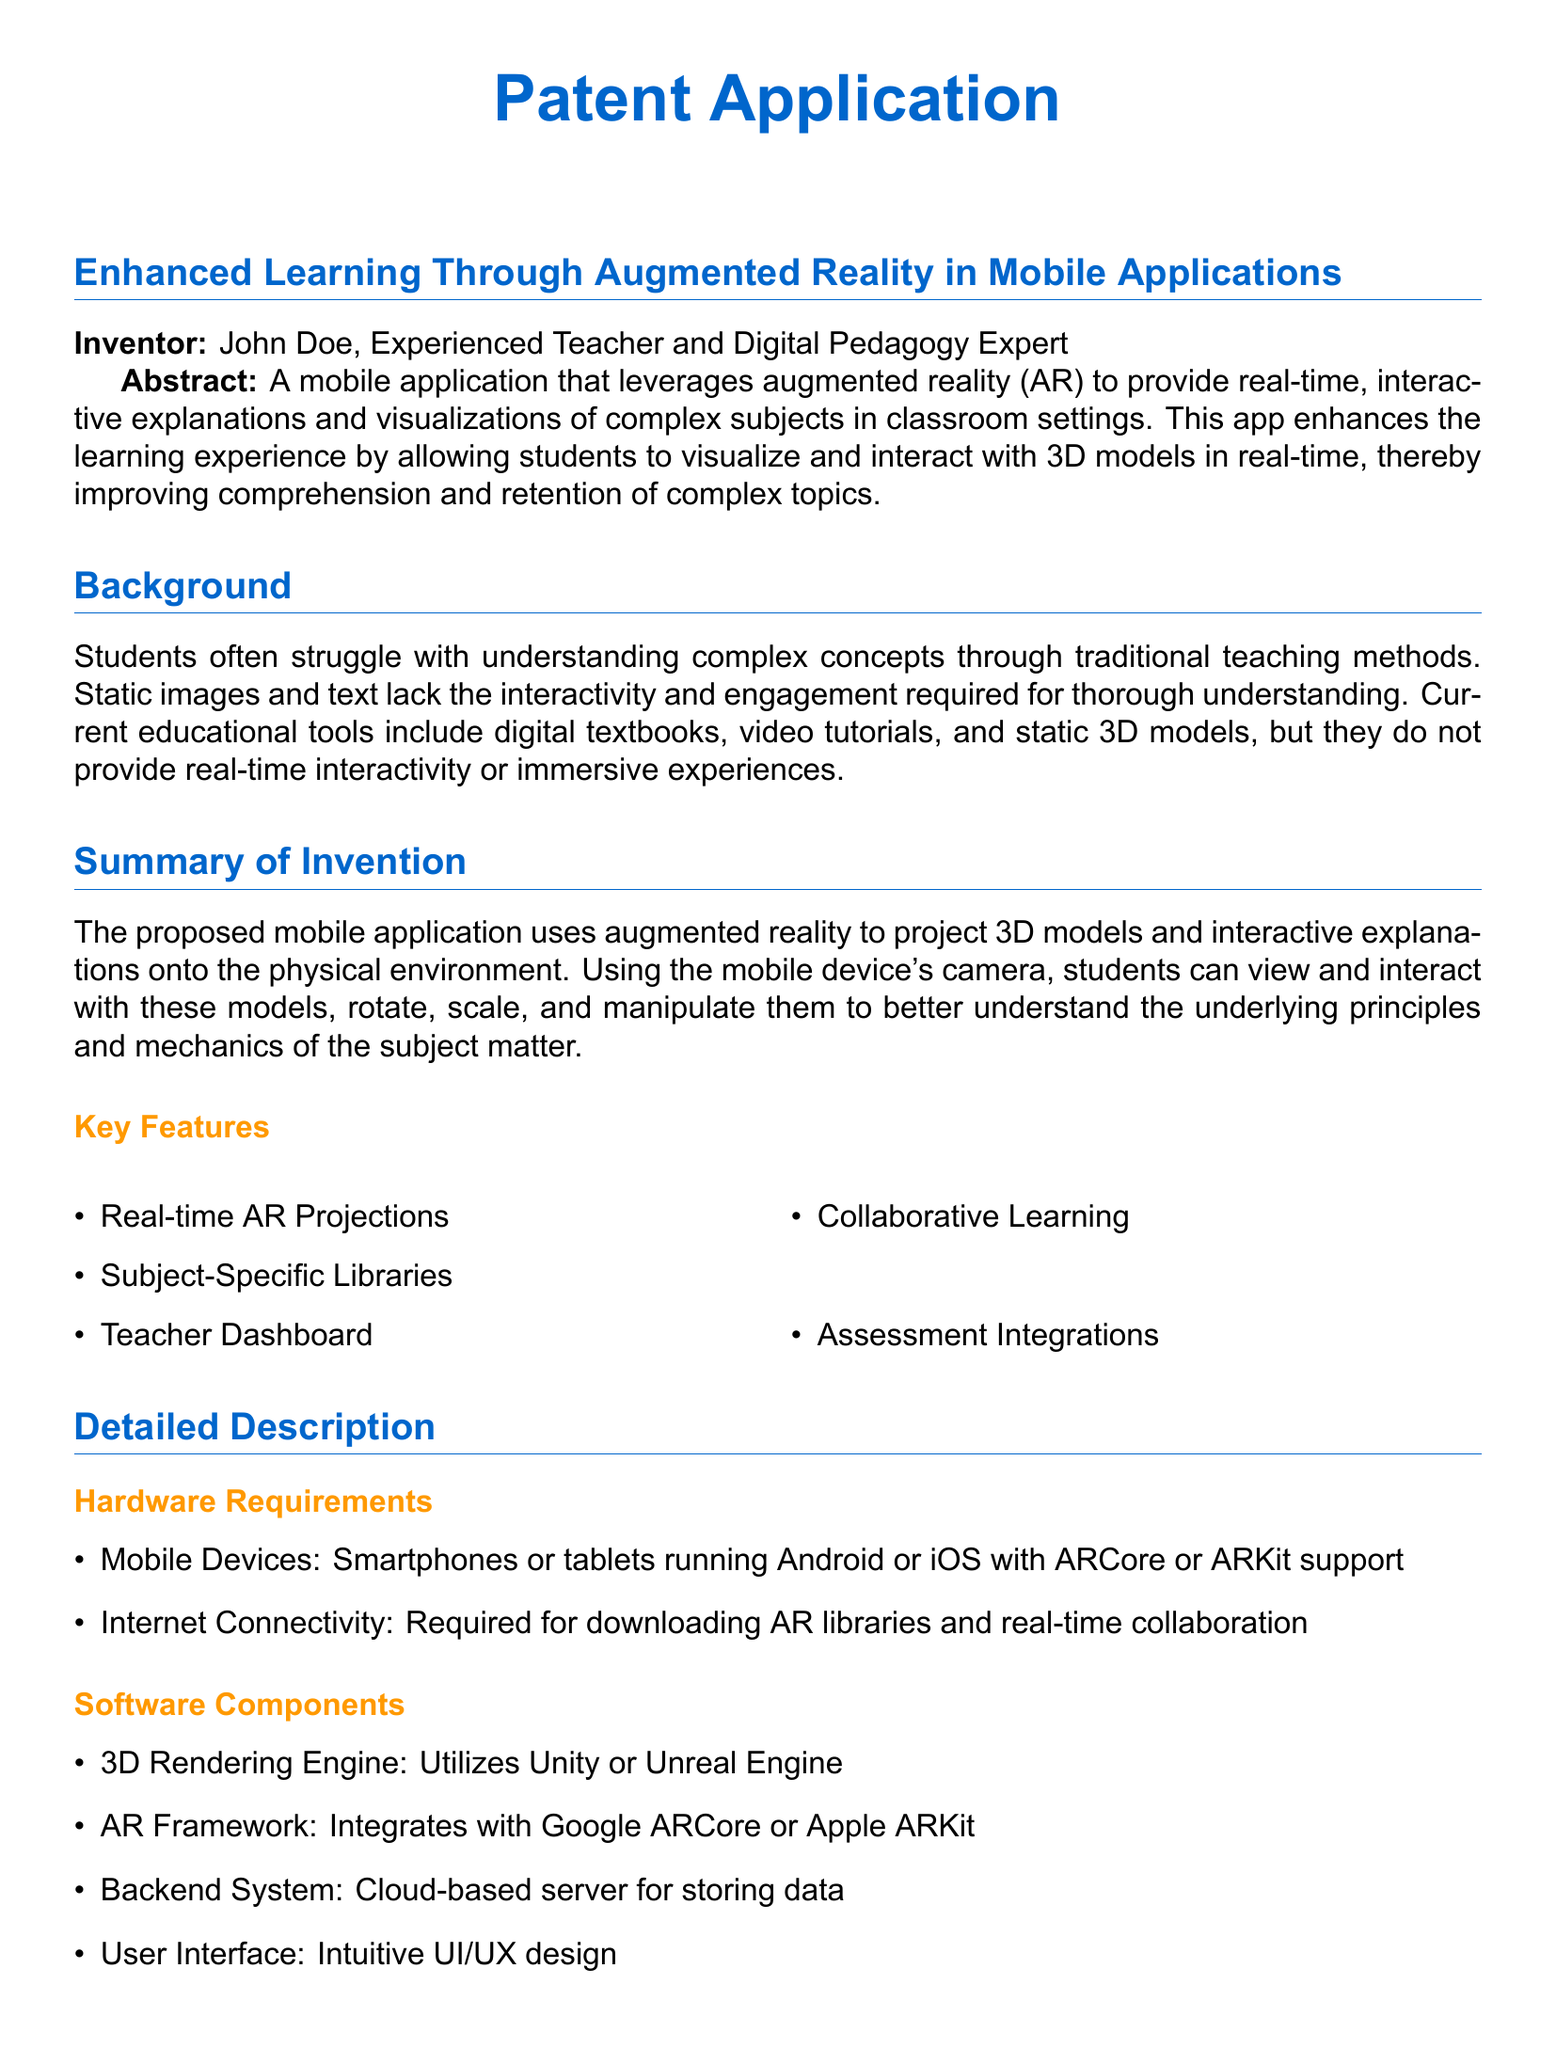What is the title of the patent application? The title of the patent application is found in the main header section of the document.
Answer: Enhanced Learning Through Augmented Reality in Mobile Applications Who is the inventor of the application? The inventor's name is specified immediately under the title section of the document.
Answer: John Doe What technology does the application leverage? The document mentions the technology used in the summary and throughout the text.
Answer: Augmented Reality What types of devices are required for the application? The hardware requirements section lists the specific devices necessary for functionality.
Answer: Smartphones or tablets What are the two main AR frameworks mentioned? The detailed description outlines the software components and specifies the frameworks used.
Answer: ARCore or ARKit What feature allows teachers to control AR content? The claims section outlines key functionalities, including teaching tools.
Answer: Teacher Dashboard How many claims are listed in the application? The number of claims is indicated by the enumerated list in the claims section of the document.
Answer: Four What type of learning does the application support? The summary of the invention highlights a specific approach to learning enabled by the app.
Answer: Collaborative Learning What is the primary benefit of using this application? The abstract provides a concise statement about the app's main advantage for students.
Answer: Improved comprehension and retention 